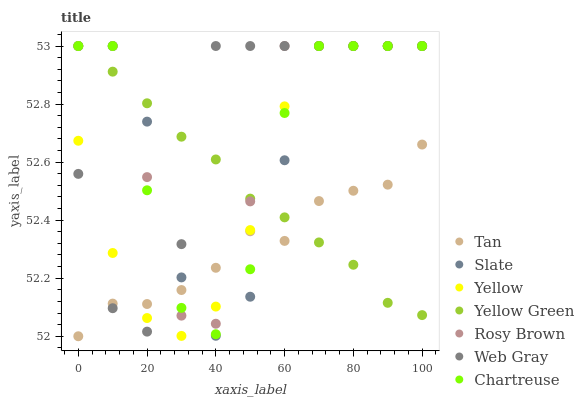Does Tan have the minimum area under the curve?
Answer yes or no. Yes. Does Web Gray have the maximum area under the curve?
Answer yes or no. Yes. Does Yellow Green have the minimum area under the curve?
Answer yes or no. No. Does Yellow Green have the maximum area under the curve?
Answer yes or no. No. Is Yellow Green the smoothest?
Answer yes or no. Yes. Is Chartreuse the roughest?
Answer yes or no. Yes. Is Slate the smoothest?
Answer yes or no. No. Is Slate the roughest?
Answer yes or no. No. Does Tan have the lowest value?
Answer yes or no. Yes. Does Slate have the lowest value?
Answer yes or no. No. Does Chartreuse have the highest value?
Answer yes or no. Yes. Does Tan have the highest value?
Answer yes or no. No. Does Slate intersect Yellow?
Answer yes or no. Yes. Is Slate less than Yellow?
Answer yes or no. No. Is Slate greater than Yellow?
Answer yes or no. No. 